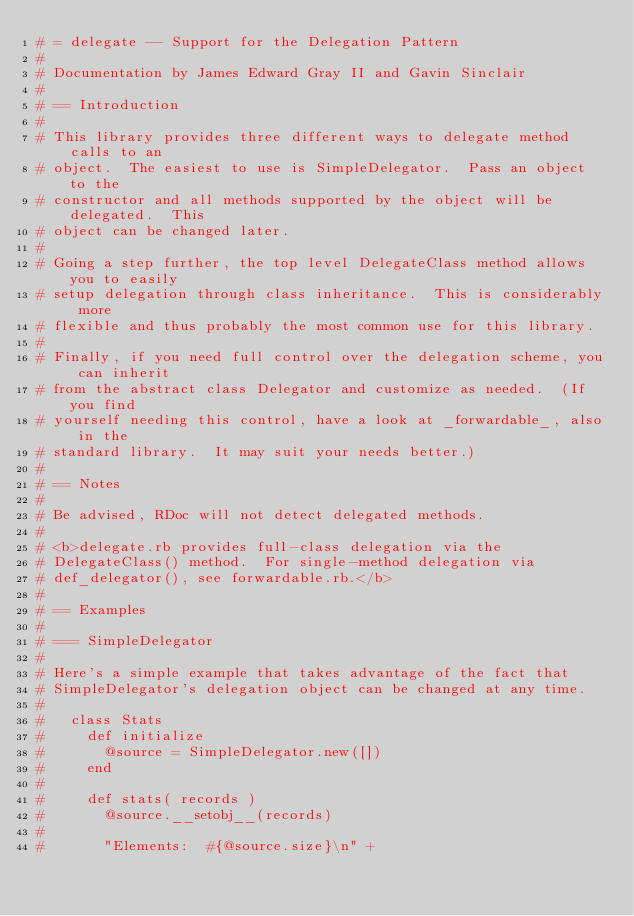Convert code to text. <code><loc_0><loc_0><loc_500><loc_500><_Ruby_># = delegate -- Support for the Delegation Pattern
#
# Documentation by James Edward Gray II and Gavin Sinclair
#
# == Introduction
#
# This library provides three different ways to delegate method calls to an
# object.  The easiest to use is SimpleDelegator.  Pass an object to the
# constructor and all methods supported by the object will be delegated.  This
# object can be changed later.
#
# Going a step further, the top level DelegateClass method allows you to easily
# setup delegation through class inheritance.  This is considerably more
# flexible and thus probably the most common use for this library.
#
# Finally, if you need full control over the delegation scheme, you can inherit
# from the abstract class Delegator and customize as needed.  (If you find
# yourself needing this control, have a look at _forwardable_, also in the
# standard library.  It may suit your needs better.)
#
# == Notes
#
# Be advised, RDoc will not detect delegated methods.
#
# <b>delegate.rb provides full-class delegation via the
# DelegateClass() method.  For single-method delegation via
# def_delegator(), see forwardable.rb.</b>
#
# == Examples
#
# === SimpleDelegator
#
# Here's a simple example that takes advantage of the fact that
# SimpleDelegator's delegation object can be changed at any time.
#
#   class Stats
#     def initialize
#       @source = SimpleDelegator.new([])
#     end
#     
#     def stats( records )
#       @source.__setobj__(records)
#       	
#       "Elements:  #{@source.size}\n" +</code> 